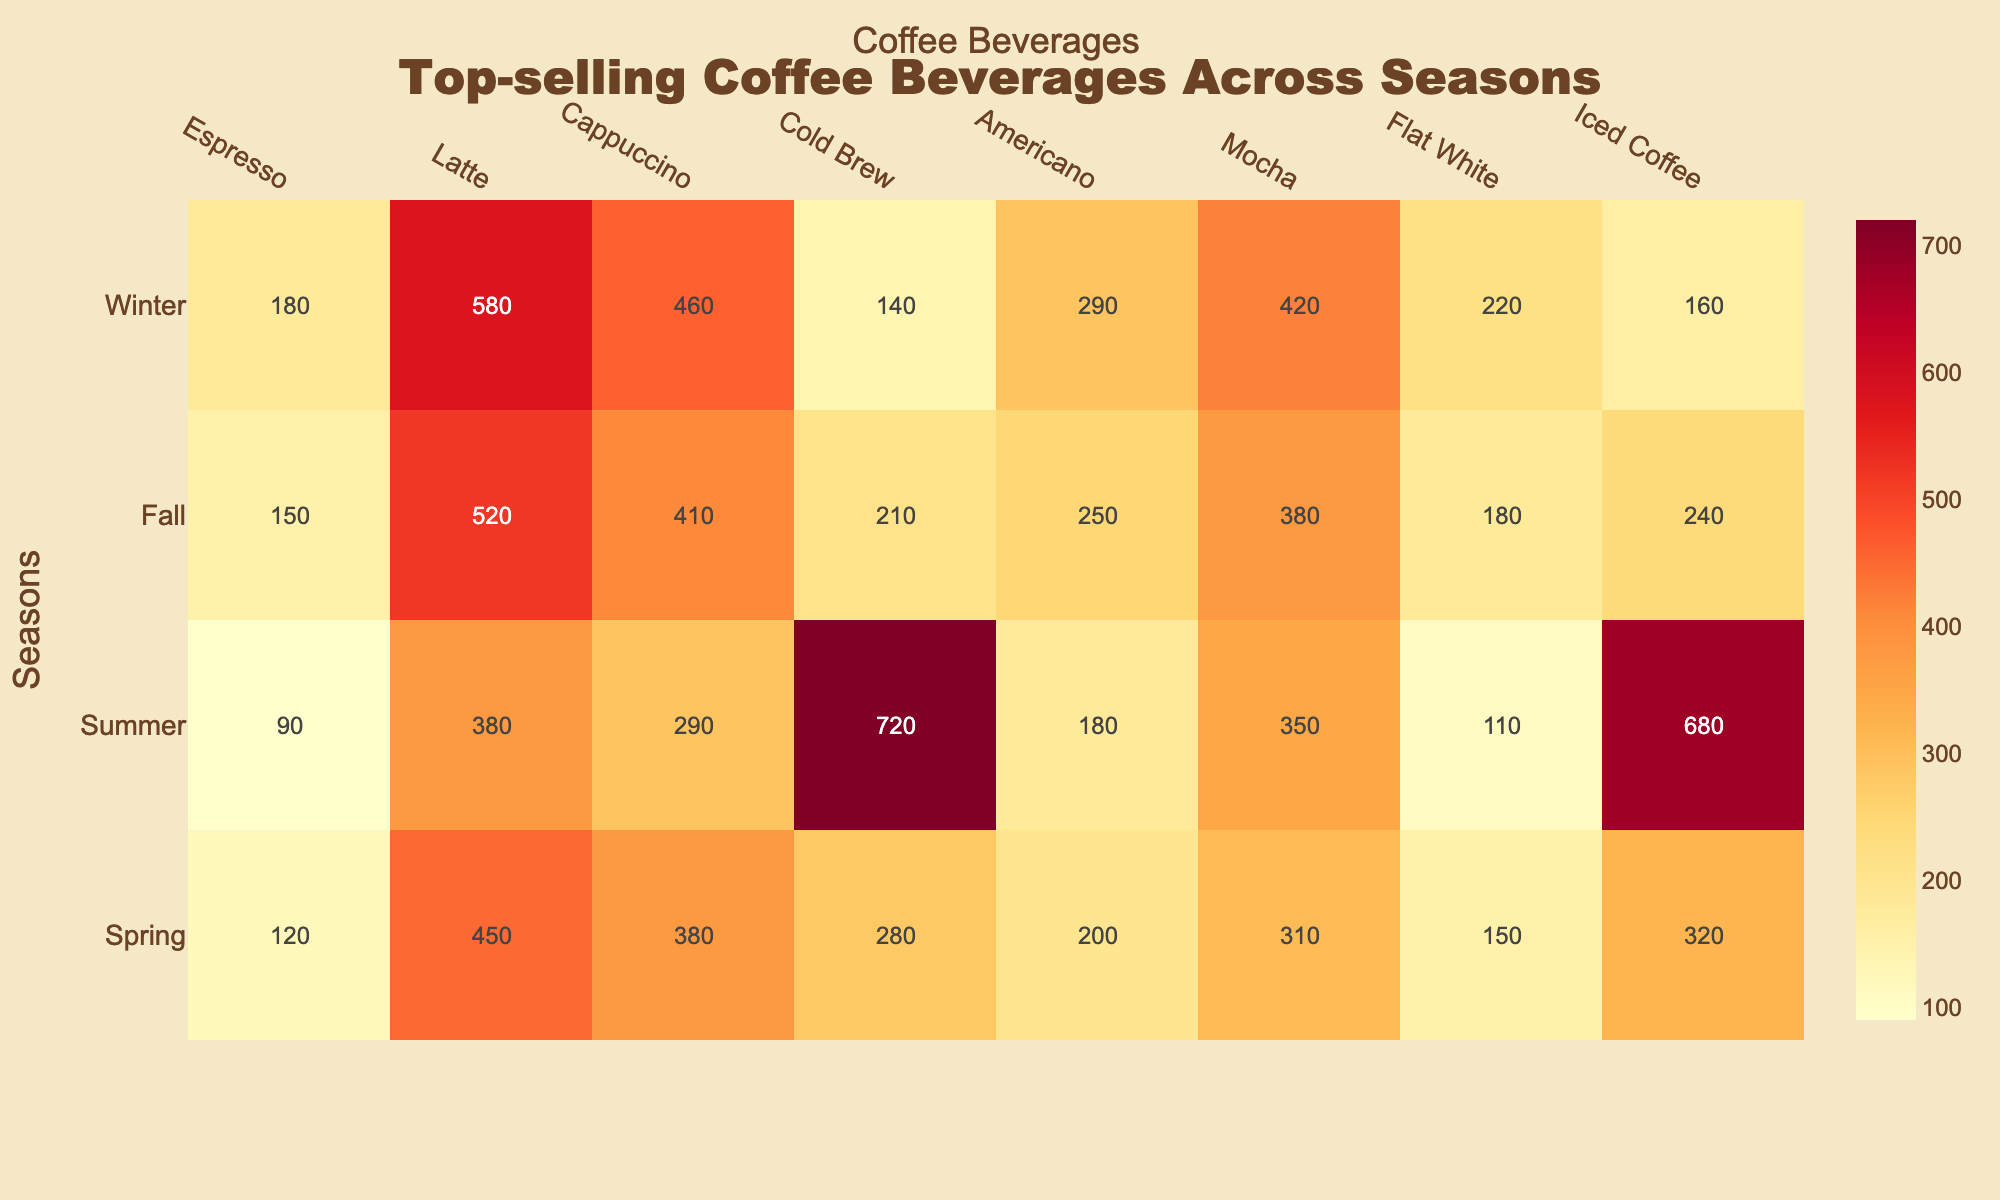What is the top-selling beverage in winter? In the winter season, the table shows that Latte has the highest sales with 580 units sold.
Answer: Latte Which beverage had the lowest sales in spring? By examining the values in spring, the beverage with the lowest sales is Flat White, which sold 150 units.
Answer: Flat White How much more Cold Brew was sold in summer compared to winter? Cold Brew sold 720 units in summer and only 140 units in winter. The difference is 720 - 140 = 580 units.
Answer: 580 What season had the highest total sales for Mocha? Looking at the data for Mocha across all seasons, winter has the highest sales with 420 units.
Answer: Winter Is the sales figure for Cappuccino in fall greater than that in spring? In fall, Cappuccino sales were 410 units, whereas in spring they were 380 units. Since 410 is greater than 380, the statement is true.
Answer: Yes What is the average sales of Iced Coffee across all seasons? To find the average, we sum the sales figures for Iced Coffee: 320 + 680 + 240 + 160 = 1400. Then we divide by the number of seasons (4), so the average is 1400 / 4 = 350.
Answer: 350 In which season did Espresso sell the most? Espresso sold the most in winter with 180 units, compared to 120 in spring, 90 in summer, and 150 in fall.
Answer: Winter What is the difference in sales between Latte in spring and fall? In spring, Latte sales were 450, and in fall, they were 520. The difference is 520 - 450 = 70, indicating that fall had higher sales.
Answer: 70 Which two beverages had the closest sales figures in summer? In summer, Cold Brew sold 720, and Iced Coffee sold 680. To find the difference, we calculate 720 - 680 = 40, making them the closest in sales.
Answer: Cold Brew and Iced Coffee 